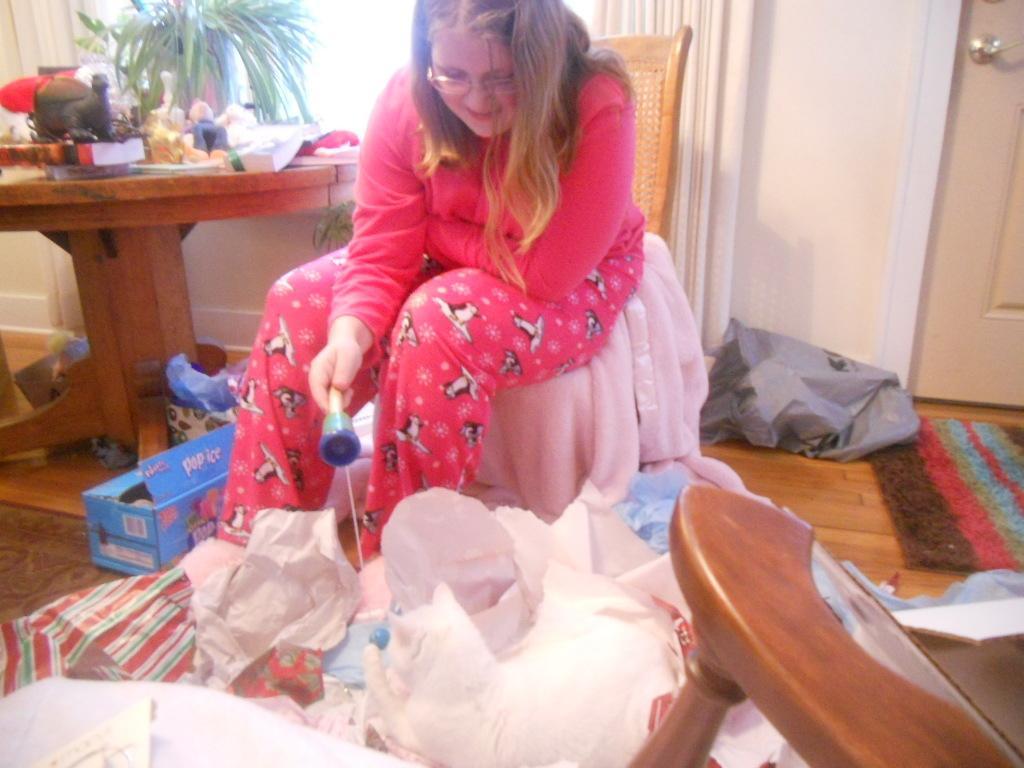Please provide a concise description of this image. In the picture I can see a woman is sitting on a chair and holding an object in the hand. I can also see white color clothes and some other color clothes on the floor. On the left side I can see a table which has some objects on it and some other objects on the floor. On the right side I can see curtains and a door. 